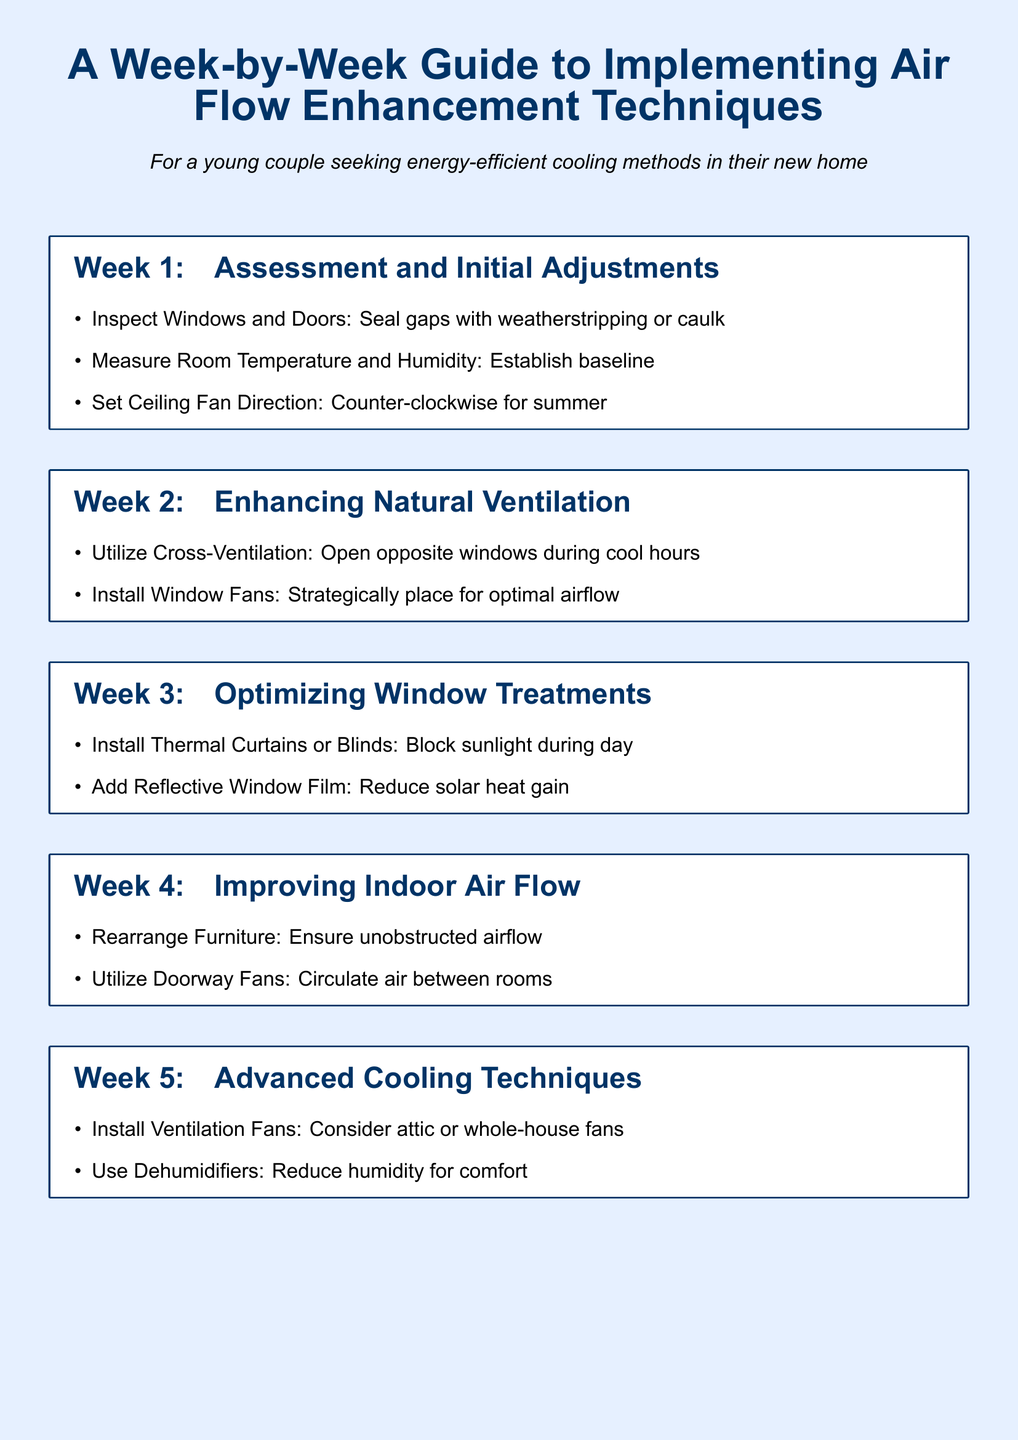What is the first week focused on? The first week centers around assessing and making initial adjustments to the home's airflow.
Answer: Assessment and Initial Adjustments What should be done to windows and doors? The document suggests sealing gaps with weatherstripping or caulk.
Answer: Seal gaps with weatherstripping or caulk What cooling technique involves opening opposite windows? This technique is called cross-ventilation, which uses natural airflow to cool the home.
Answer: Cross-Ventilation What kind of curtains should be installed to block sunlight? Thermal curtains or blinds are recommended for blocking sunlight during the day.
Answer: Thermal Curtains or Blinds What is one advanced cooling technique suggested? The document recommends installing ventilation fans, such as attic or whole-house fans.
Answer: Install Ventilation Fans How can indoor air flow be improved? One suggested method is to rearrange furniture for unobstructed airflow.
Answer: Rearrange Furniture What device can reduce humidity for comfort? A dehumidifier can be used to reduce humidity levels in the home.
Answer: Dehumidifiers What should be the ceiling fan direction for summer? The ceiling fan should be set to rotate counter-clockwise during summer.
Answer: Counter-clockwise In which week is improving indoor airflow addressed? Improving indoor airflow is discussed in Week 4 of the itinerary.
Answer: Week 4 